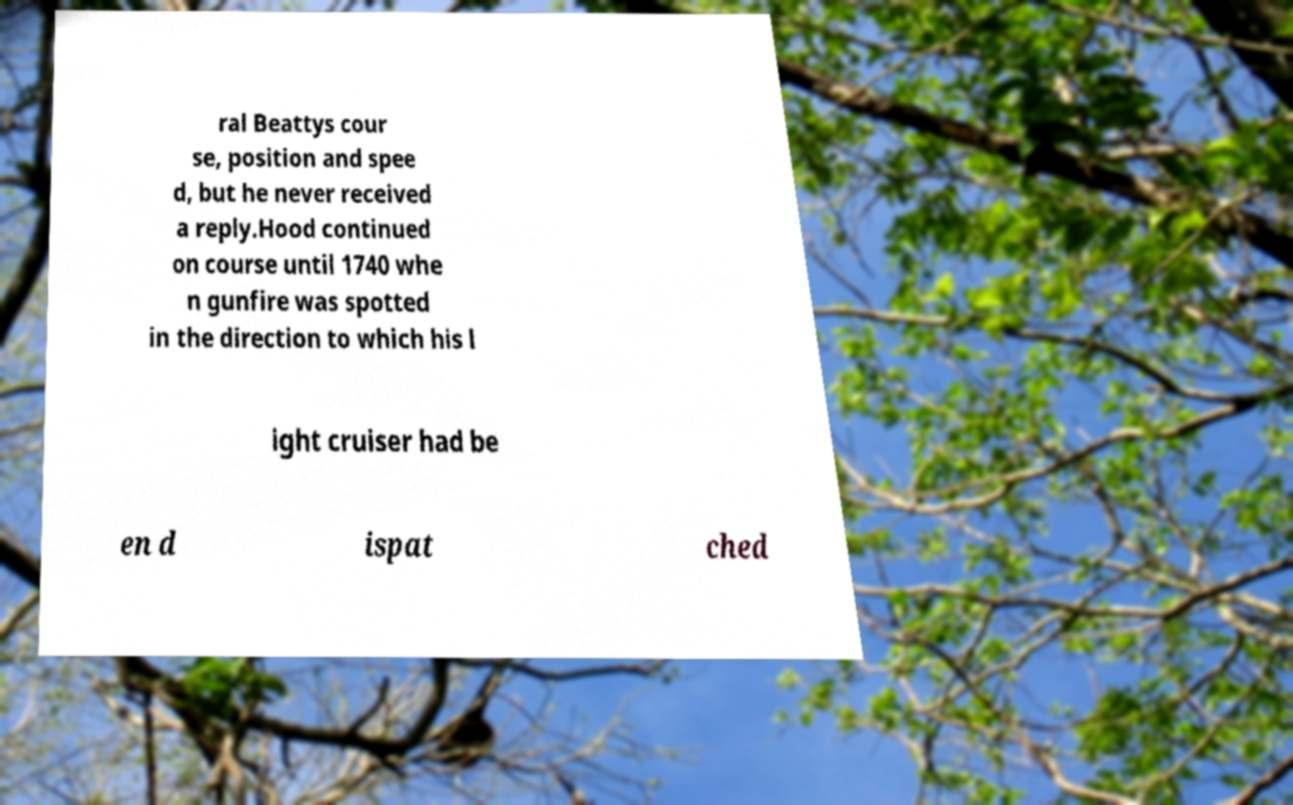Could you assist in decoding the text presented in this image and type it out clearly? ral Beattys cour se, position and spee d, but he never received a reply.Hood continued on course until 1740 whe n gunfire was spotted in the direction to which his l ight cruiser had be en d ispat ched 